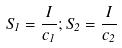<formula> <loc_0><loc_0><loc_500><loc_500>S _ { 1 } = \frac { I } { c _ { 1 } } ; S _ { 2 } = \frac { I } { c _ { 2 } }</formula> 